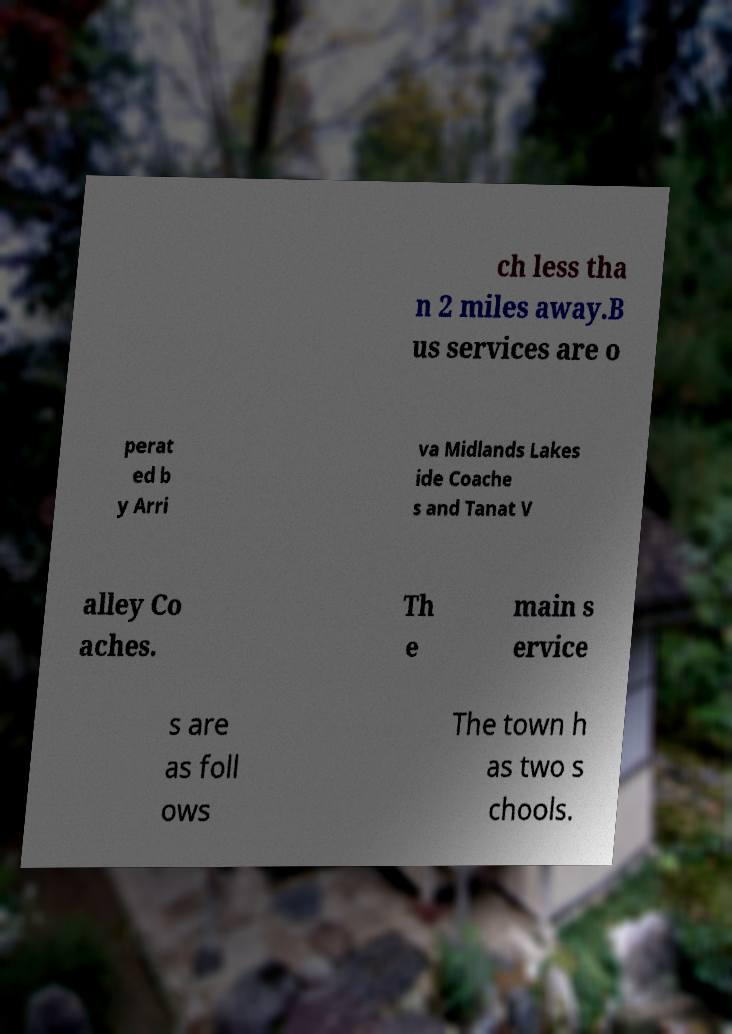Could you assist in decoding the text presented in this image and type it out clearly? ch less tha n 2 miles away.B us services are o perat ed b y Arri va Midlands Lakes ide Coache s and Tanat V alley Co aches. Th e main s ervice s are as foll ows The town h as two s chools. 